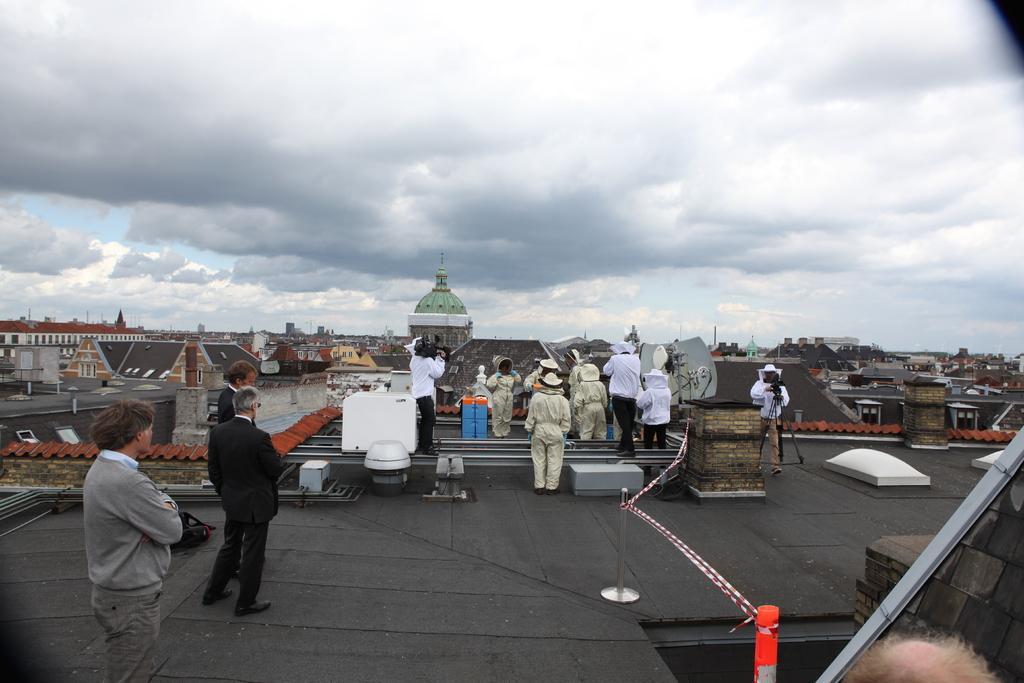Please provide a concise description of this image. In this image we can see people. There are houses. At the top of the image there is sky and clouds. 